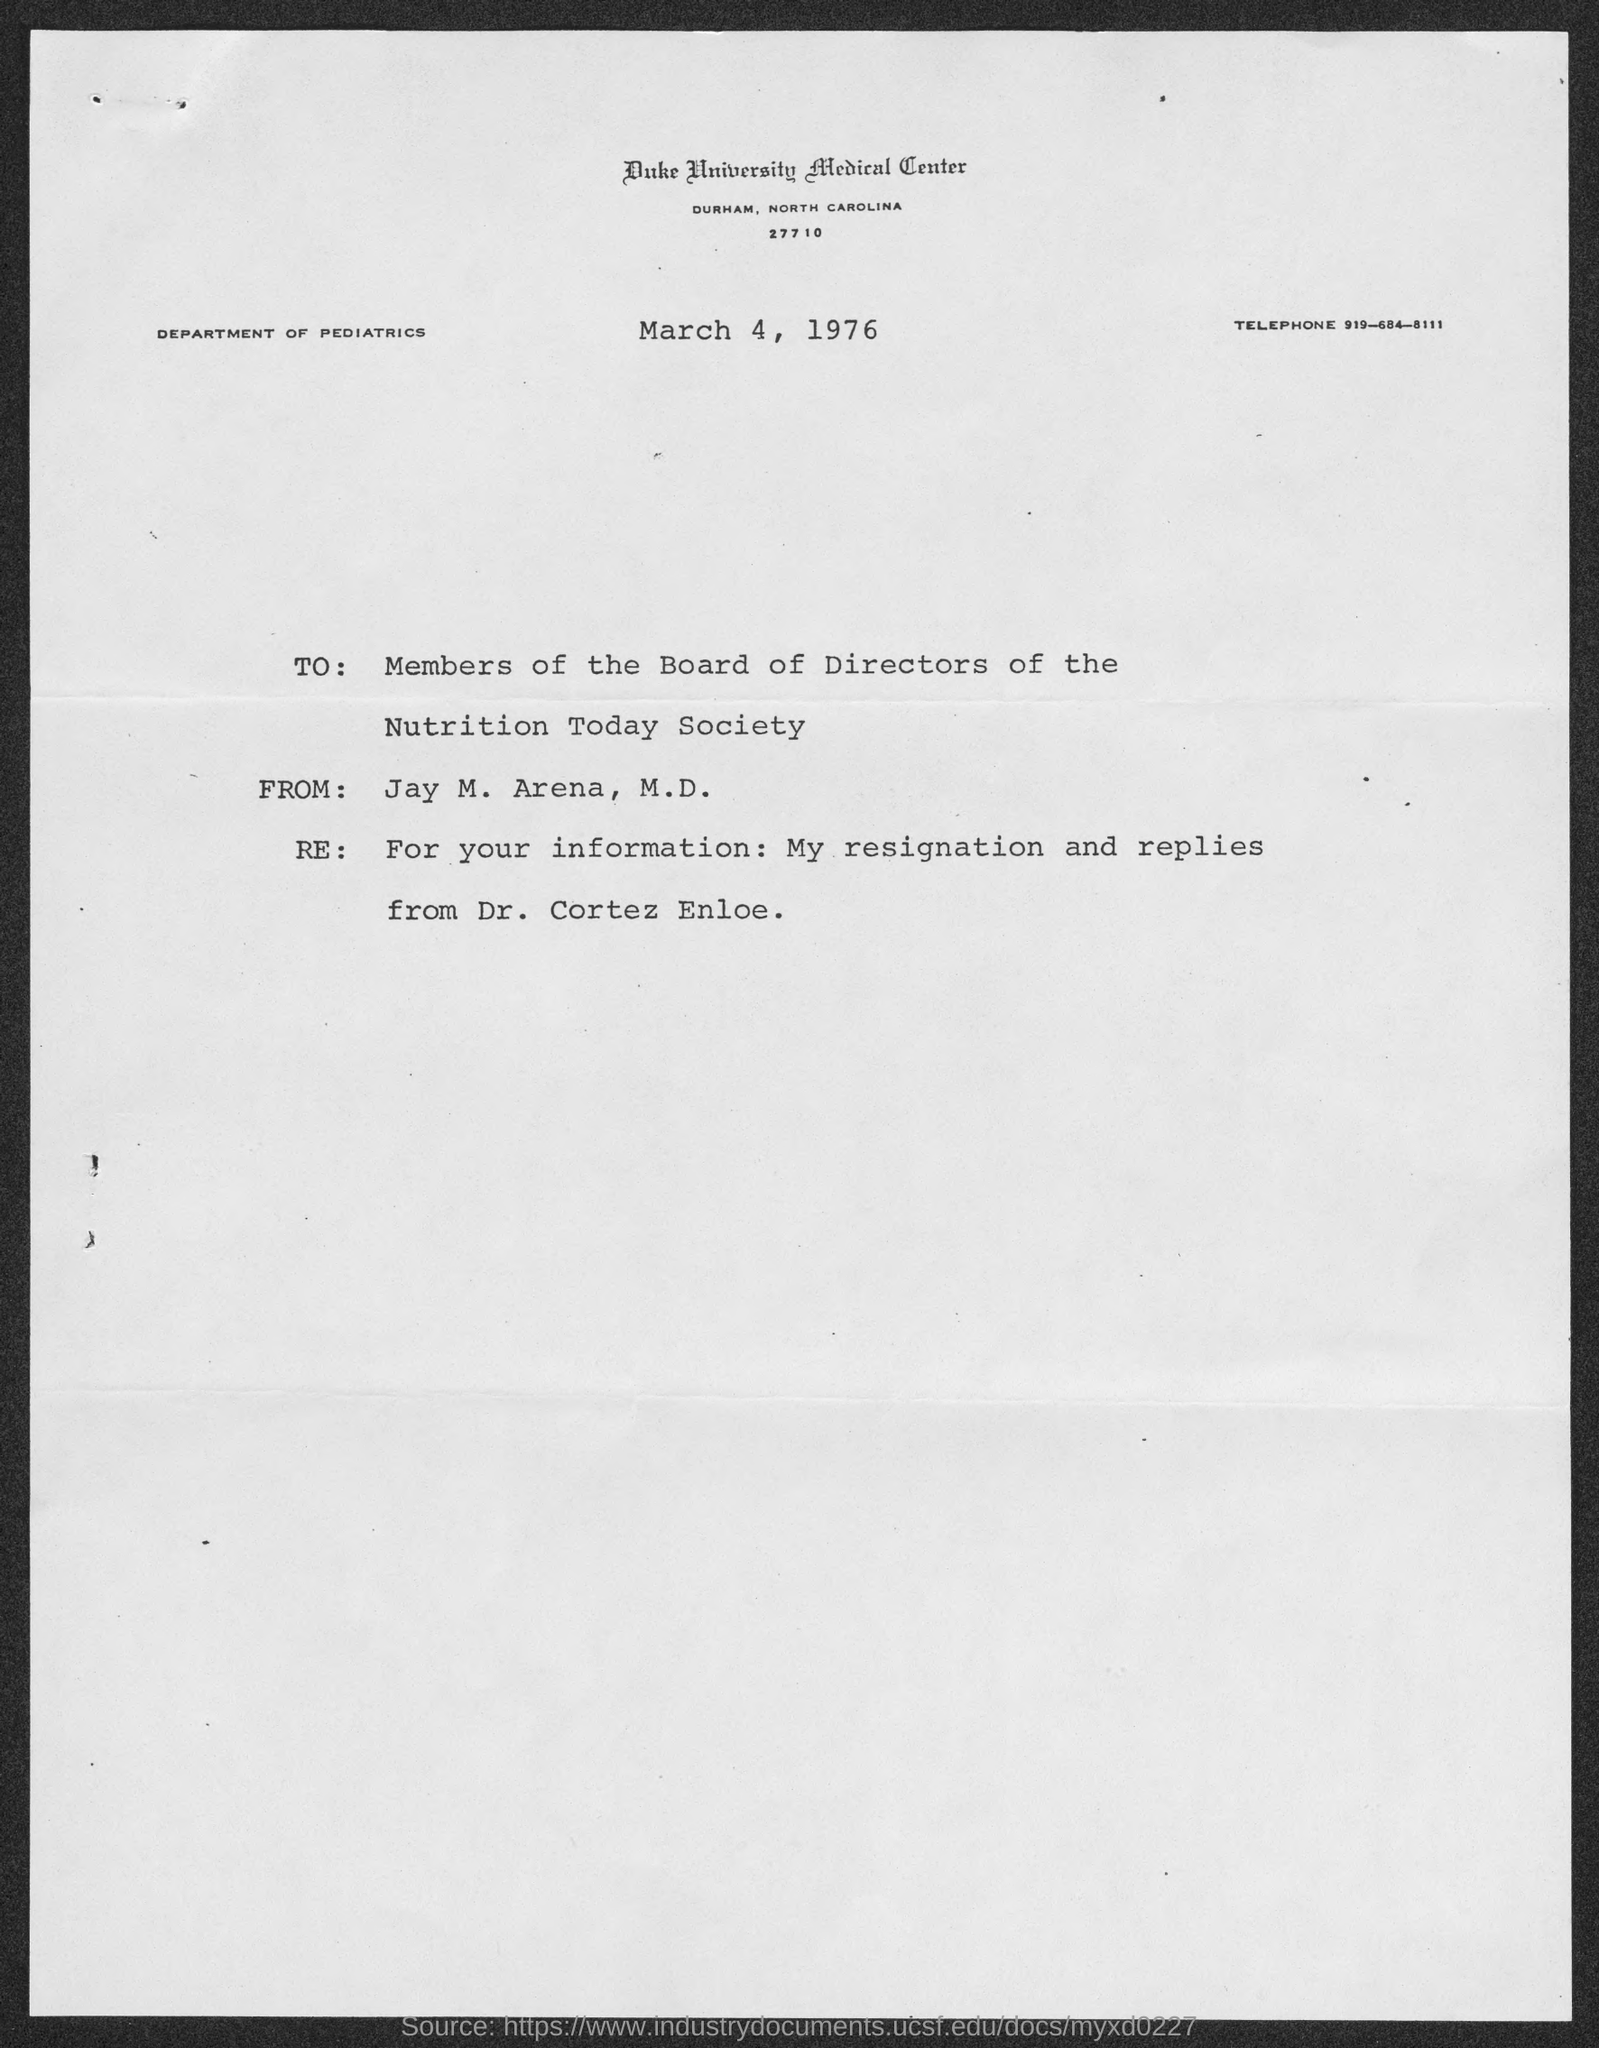Mention a couple of crucial points in this snapshot. The sender of this document is Jay M. Arena, M.D. The header of the document mentions Duke University Medical Center. The header of the document indicates that the DEPARTMENT OF PEDIATRICS is mentioned in the document. The date mentioned in this document is March 4, 1976. The telephone number provided in this document is 919-684-8111. 